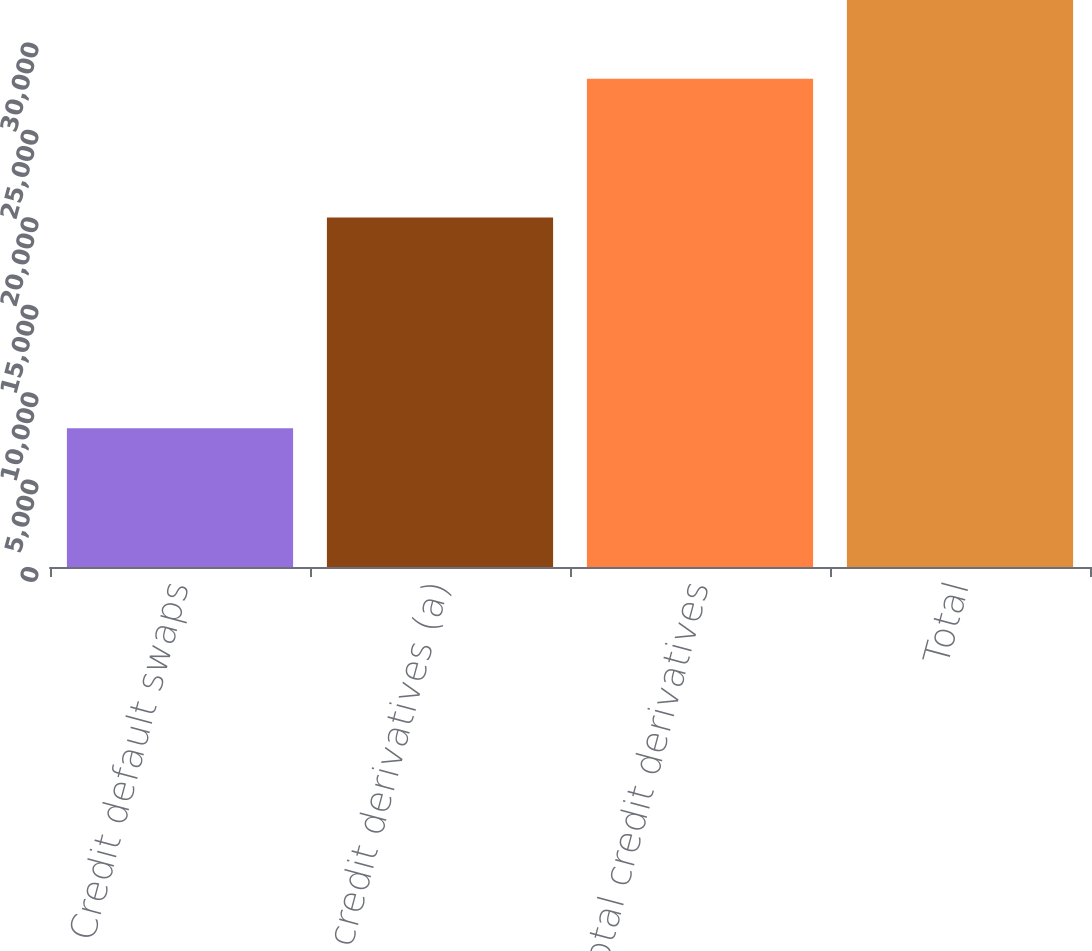<chart> <loc_0><loc_0><loc_500><loc_500><bar_chart><fcel>Credit default swaps<fcel>Other credit derivatives (a)<fcel>Total credit derivatives<fcel>Total<nl><fcel>7935<fcel>19991<fcel>27926<fcel>32431<nl></chart> 